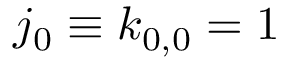<formula> <loc_0><loc_0><loc_500><loc_500>j _ { 0 } \equiv k _ { 0 , 0 } = 1</formula> 